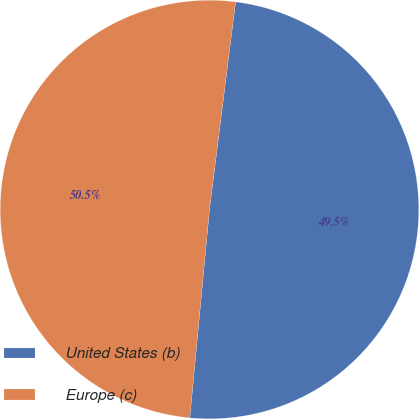Convert chart. <chart><loc_0><loc_0><loc_500><loc_500><pie_chart><fcel>United States (b)<fcel>Europe (c)<nl><fcel>49.51%<fcel>50.49%<nl></chart> 